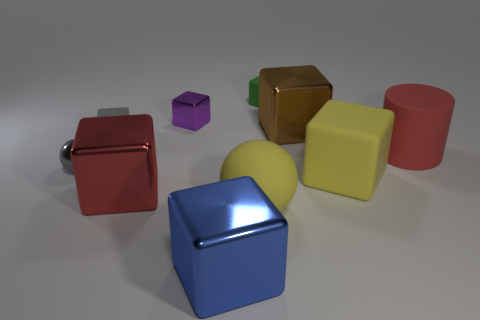Is there anything else that has the same shape as the red rubber object?
Your response must be concise. No. Is there a large red object on the left side of the red thing that is left of the large yellow matte object in front of the red shiny block?
Give a very brief answer. No. What number of big spheres are the same color as the large cylinder?
Your response must be concise. 0. There is a blue metal thing that is the same size as the yellow matte block; what is its shape?
Keep it short and to the point. Cube. There is a red metal block; are there any tiny spheres right of it?
Your response must be concise. No. Does the brown metallic cube have the same size as the red rubber cylinder?
Give a very brief answer. Yes. The tiny matte thing that is to the right of the big blue metal object has what shape?
Make the answer very short. Cube. Is there a red cube of the same size as the blue cube?
Make the answer very short. Yes. There is a brown cube that is the same size as the blue cube; what is its material?
Provide a short and direct response. Metal. How big is the sphere right of the big red block?
Your answer should be very brief. Large. 